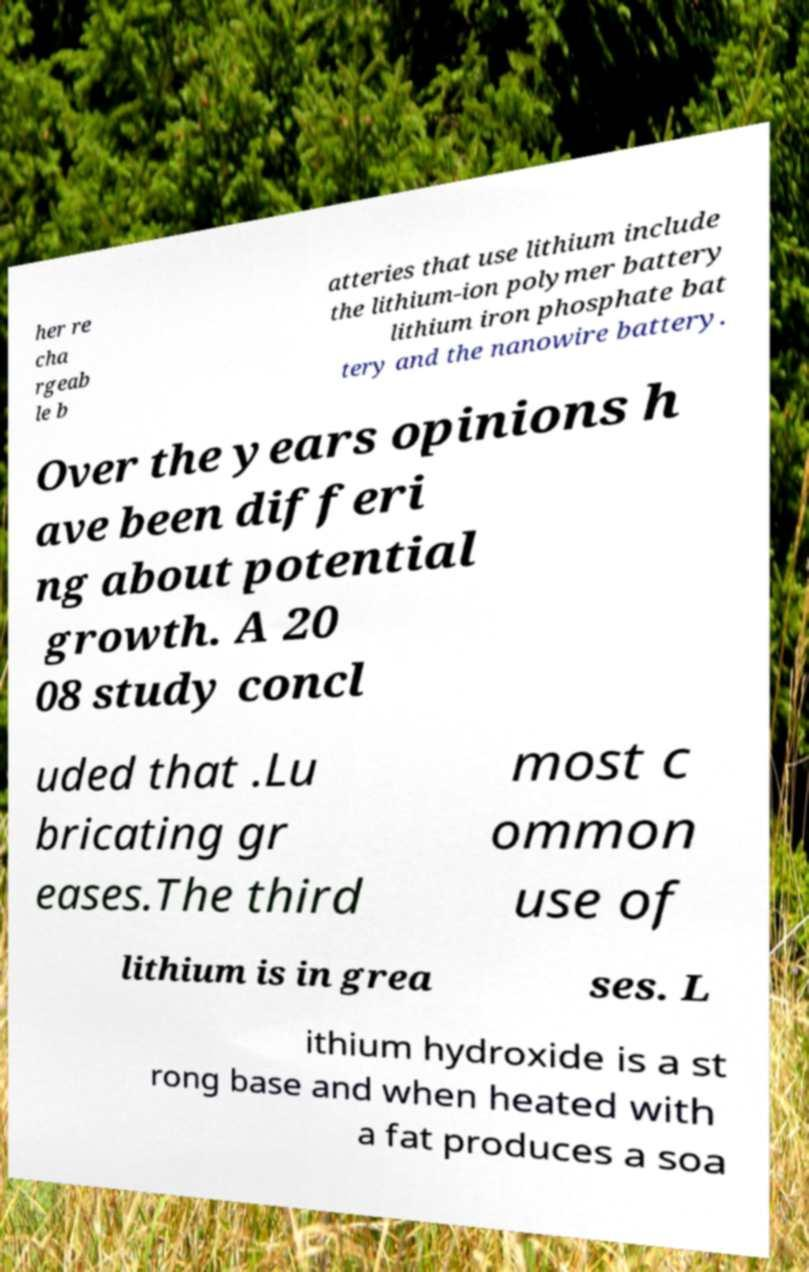What messages or text are displayed in this image? I need them in a readable, typed format. her re cha rgeab le b atteries that use lithium include the lithium-ion polymer battery lithium iron phosphate bat tery and the nanowire battery. Over the years opinions h ave been differi ng about potential growth. A 20 08 study concl uded that .Lu bricating gr eases.The third most c ommon use of lithium is in grea ses. L ithium hydroxide is a st rong base and when heated with a fat produces a soa 